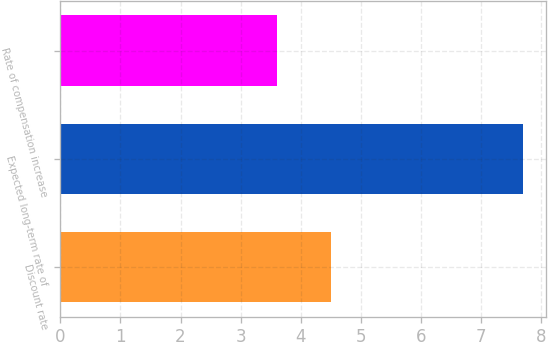Convert chart to OTSL. <chart><loc_0><loc_0><loc_500><loc_500><bar_chart><fcel>Discount rate<fcel>Expected long-term rate of<fcel>Rate of compensation increase<nl><fcel>4.5<fcel>7.7<fcel>3.6<nl></chart> 